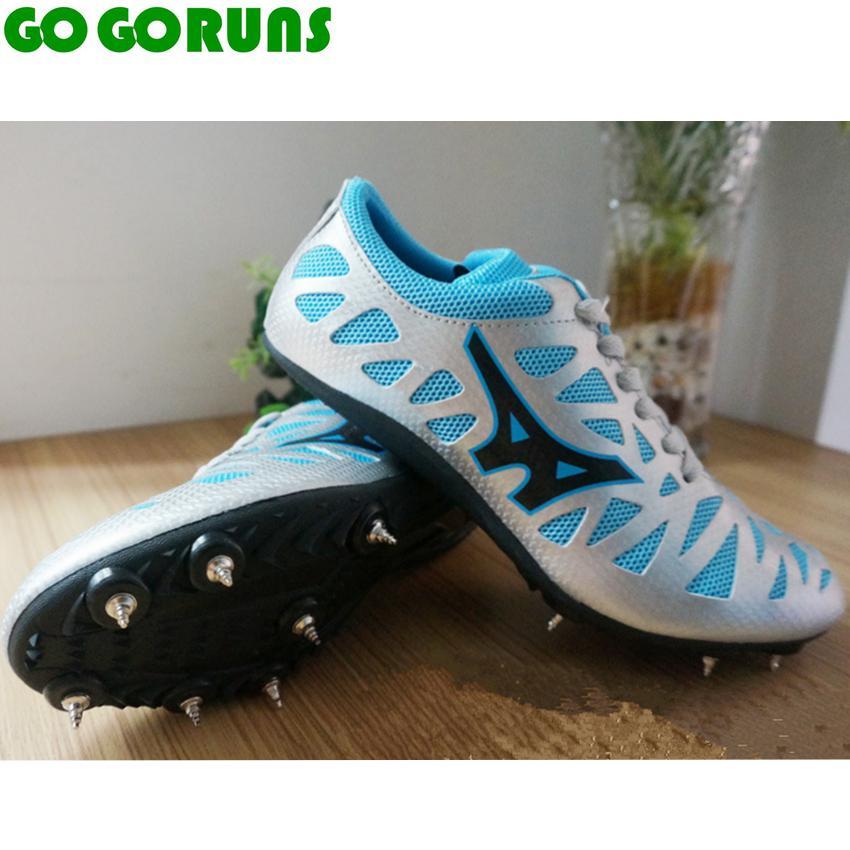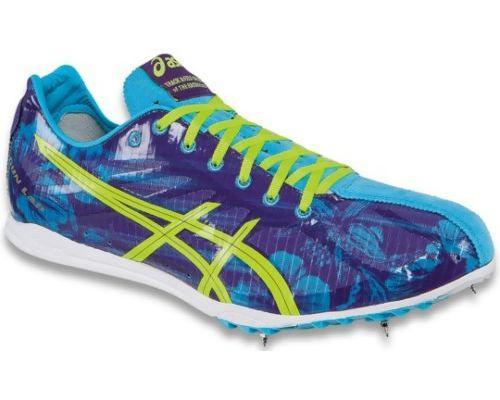The first image is the image on the left, the second image is the image on the right. For the images shown, is this caption "One image contains a single, mostly blue shoe, and the other image shows a pair of shoes, one with its sole turned to the camera." true? Answer yes or no. Yes. The first image is the image on the left, the second image is the image on the right. Examine the images to the left and right. Is the description "The right image contains exactly one blue sports tennis shoe." accurate? Answer yes or no. Yes. 